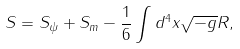<formula> <loc_0><loc_0><loc_500><loc_500>S = S _ { \psi } + S _ { m } - \frac { 1 } { 6 } \int d ^ { 4 } x \sqrt { - g } R ,</formula> 